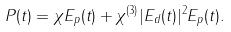<formula> <loc_0><loc_0><loc_500><loc_500>P ( t ) = \chi E _ { p } ( t ) + \chi ^ { ( 3 ) } | E _ { d } ( t ) | ^ { 2 } E _ { p } ( t ) .</formula> 